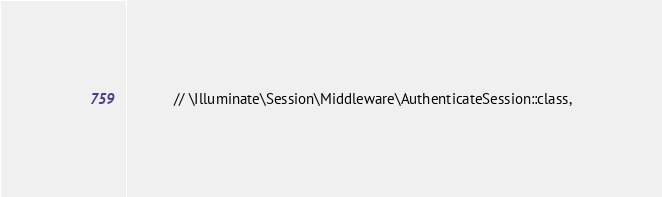Convert code to text. <code><loc_0><loc_0><loc_500><loc_500><_PHP_>            // \Illuminate\Session\Middleware\AuthenticateSession::class,</code> 